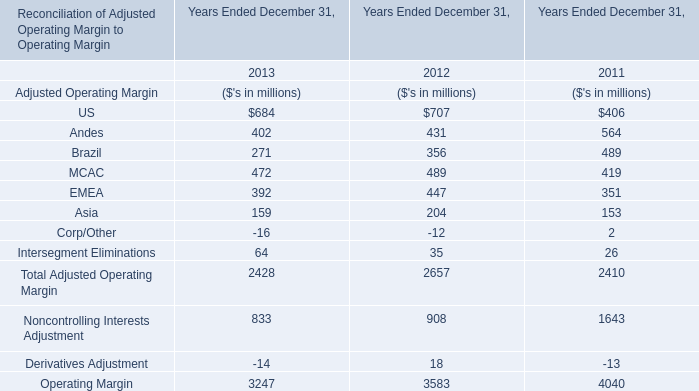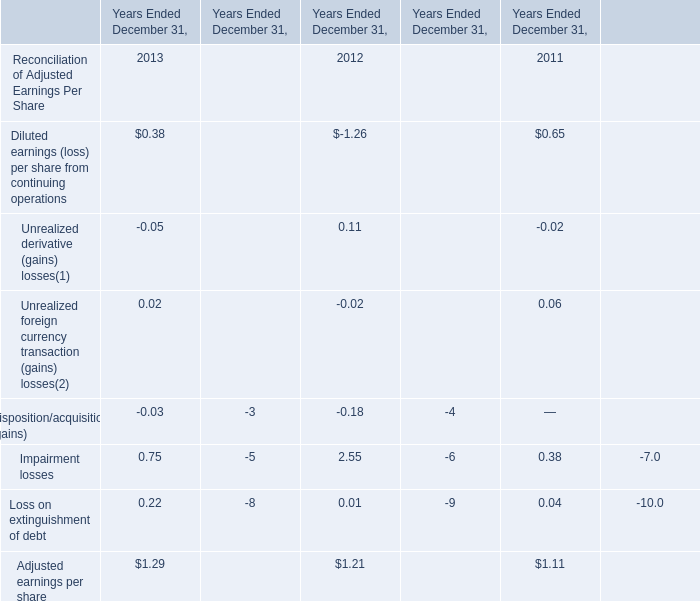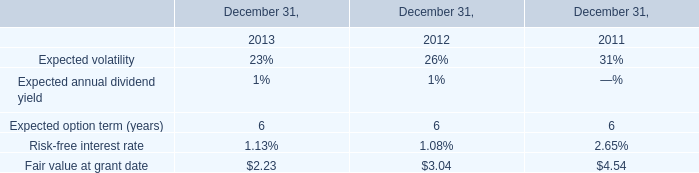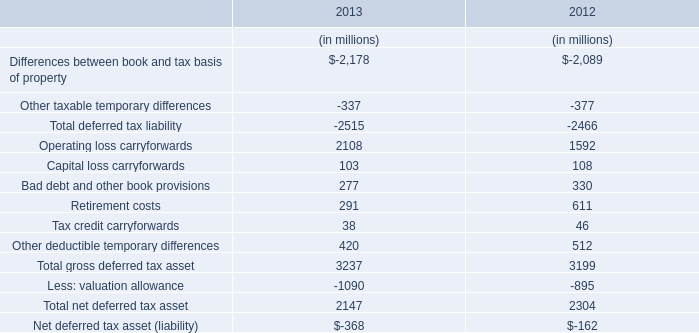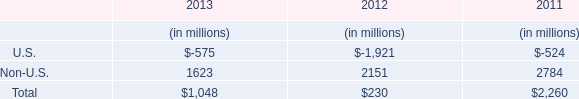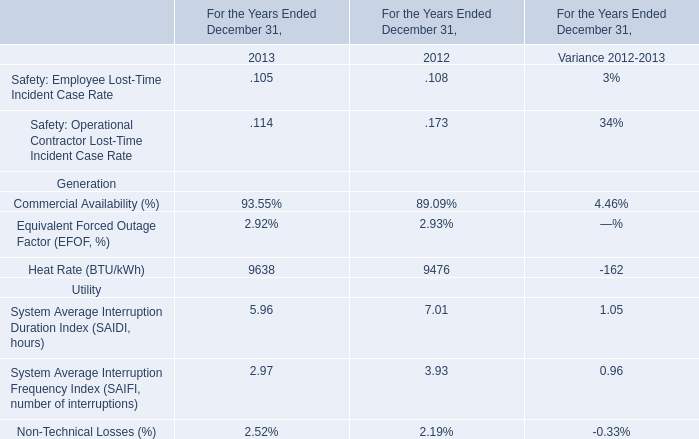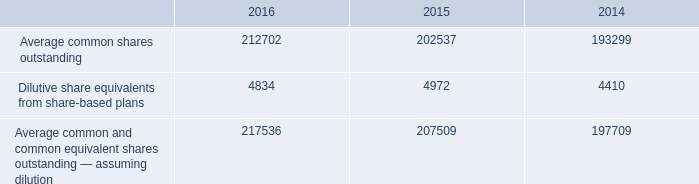what is the mathematical range of dilutive share equivalents from share-based plans for 2014-2016? 
Computations: (4972 - 4410)
Answer: 562.0. 